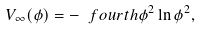<formula> <loc_0><loc_0><loc_500><loc_500>V _ { \infty } ( \phi ) = - \ f o u r t h \phi ^ { 2 } \ln \phi ^ { 2 } ,</formula> 